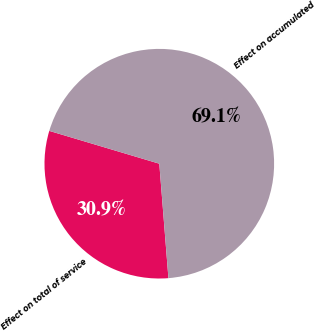Convert chart to OTSL. <chart><loc_0><loc_0><loc_500><loc_500><pie_chart><fcel>Effect on total of service<fcel>Effect on accumulated<nl><fcel>30.88%<fcel>69.12%<nl></chart> 